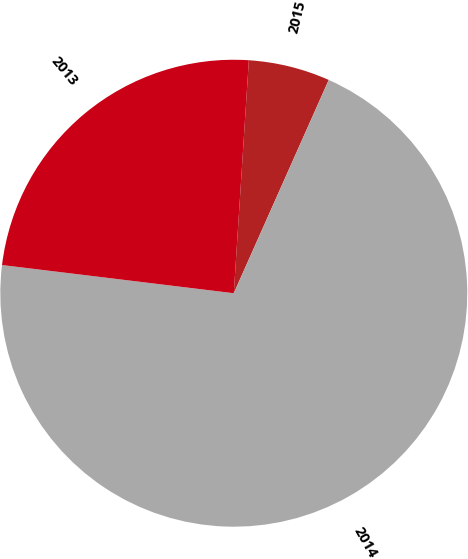Convert chart to OTSL. <chart><loc_0><loc_0><loc_500><loc_500><pie_chart><fcel>2015<fcel>2014<fcel>2013<nl><fcel>5.64%<fcel>70.26%<fcel>24.1%<nl></chart> 